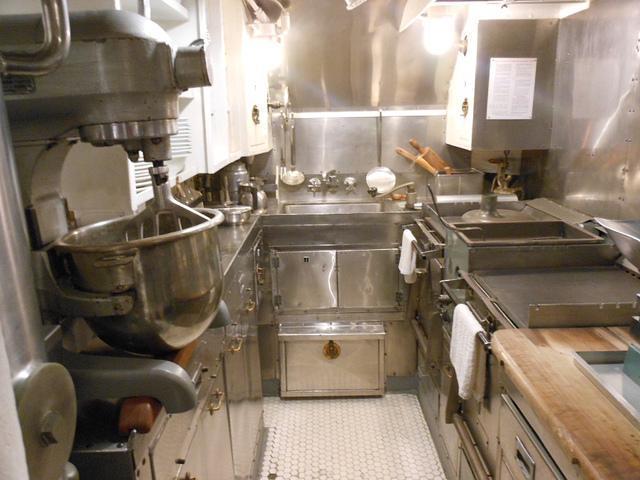How is dough kneaded here?
Answer the question by selecting the correct answer among the 4 following choices.
Options: In sink, by machine, with knives, hand only. By machine. 